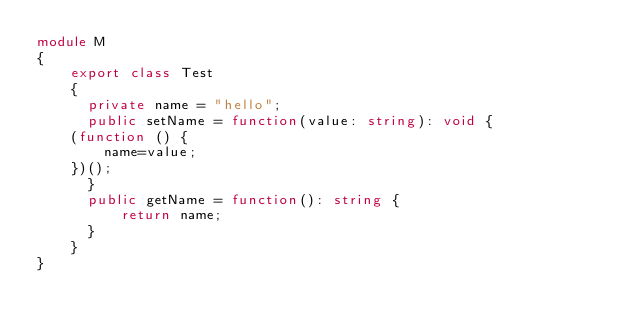<code> <loc_0><loc_0><loc_500><loc_500><_TypeScript_>module M
{
    export class Test
    {
      private name = "hello";
      public setName = function(value: string): void {
	  (function () {
	      name=value;
	  })();
      }
      public getName = function(): string {
          return name;
      }
    }
}


</code> 